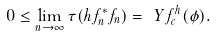<formula> <loc_0><loc_0><loc_500><loc_500>0 \leq \lim _ { n \to \infty } \tau ( h f _ { n } ^ { * } f _ { n } ) = \ Y f _ { c } ^ { h } ( \phi ) .</formula> 